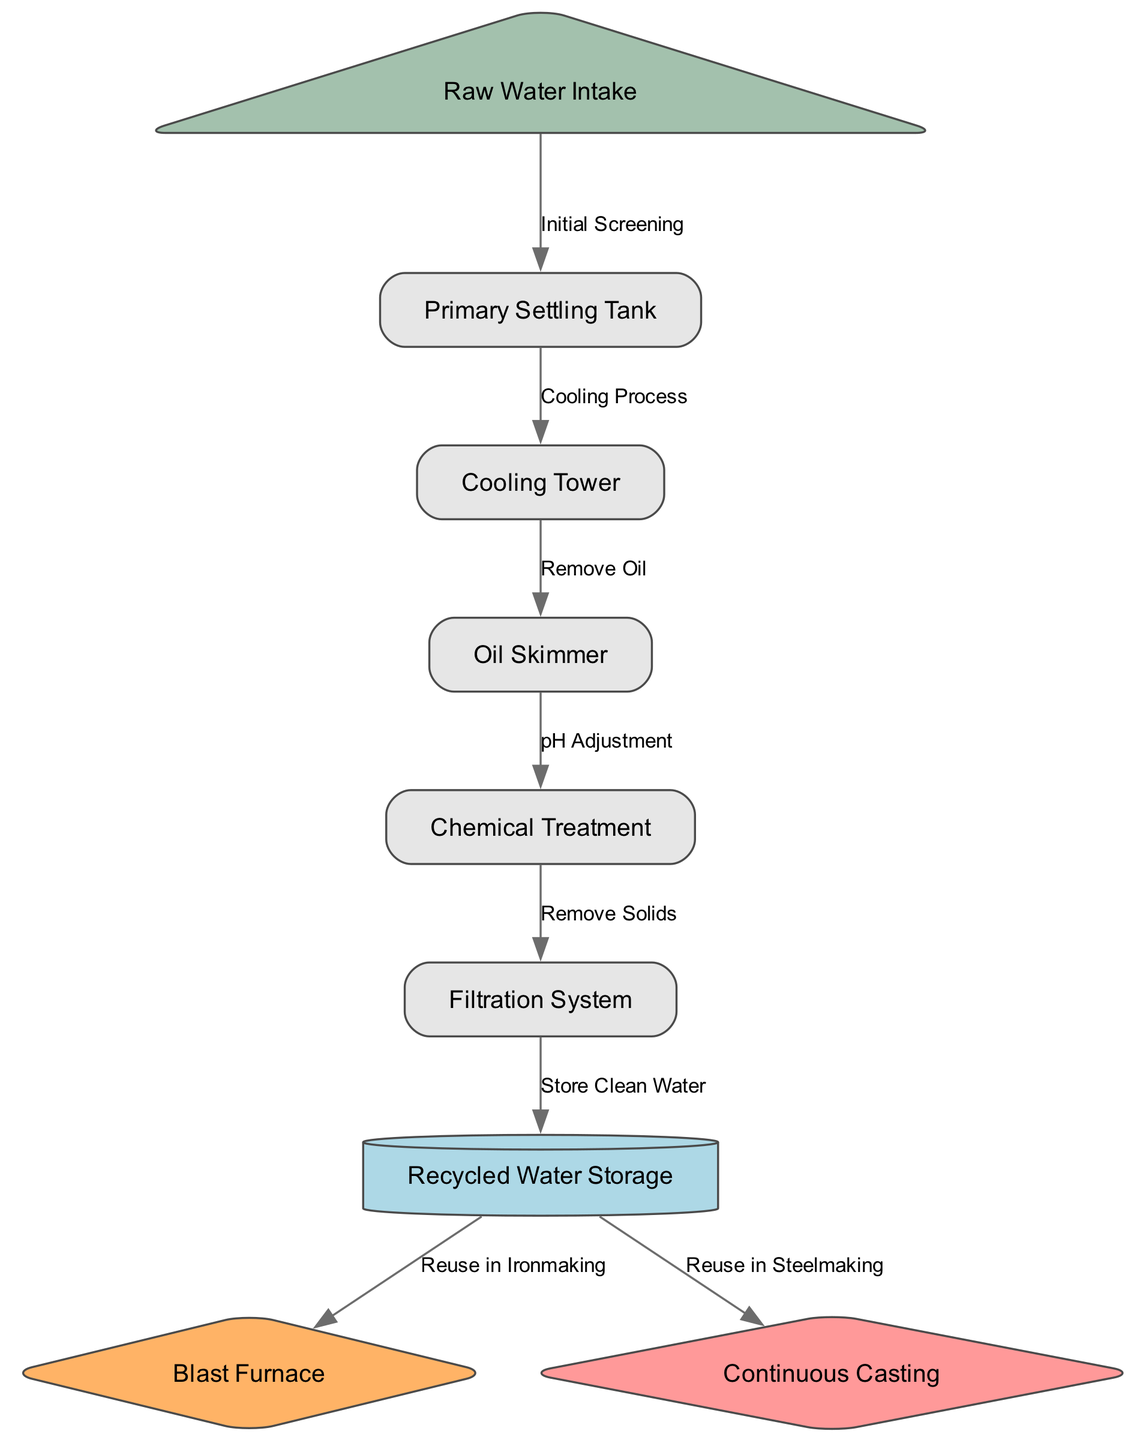What is the first step in the water treatment process? The first step is the Raw Water Intake, where raw water is gathered before treatment begins.
Answer: Raw Water Intake How many nodes are in the diagram? To find the number of nodes, we count the distinct elements listed in the nodes section of the diagram data. There are a total of 9 nodes.
Answer: 9 What type of treatment occurs after the Oil Skimmer? Following the Oil Skimmer, the water undergoes Chemical Treatment, where additional processing occurs to adjust chemical properties.
Answer: Chemical Treatment What is stored in the Recycled Water Storage? The Recycled Water Storage holds clean water that has been treated and filtered, making it ready for reuse.
Answer: Clean Water Which two processes use water from the Recycled Water Storage? The processes are the Blast Furnace and Continuous Casting, both of which utilize the treated water for steelmaking operations.
Answer: Blast Furnace and Continuous Casting What is the purpose of the Cooling Tower? The Cooling Tower's purpose is to cool the water after it has been used in the industrial process before further treatment.
Answer: Cool the water Describe the transition from the Primary Settling Tank to the Cooling Tower. The transition occurs through the Cooling Process, where water is transferred from the Primary Settling Tank to the Cooling Tower for cooling treatment after settling.
Answer: Cooling Process How does the water change after the Filtration System? After passing through the Filtration System, the water is stored as Clean Water in the Recycled Water Storage, indicating it has been filtered of solids and impurities.
Answer: Clean Water What comes after the Chemical Treatment? Following Chemical Treatment, the water moves to the Filtration System for solid removal, which is essential for ensuring clean water is stored later.
Answer: Filtration System 